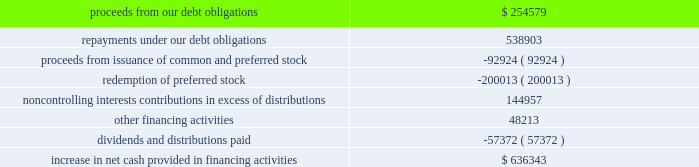Sl green realty corp .
It happens here 2012 annual report 59 | 59 during the year ended december a031 , 2012 , when compared to the year ended december a031 , 2011 , we used cash for the follow- ing financing activities ( in thousands ) : .
Ca pita liz ation | as of december a0 31 , 2012 , we had 91249632 shares of common stock , 2759758 units of lim- ited partnership interest in the operating partnership held by persons other than the company , 66668 a0 performance based ltip units , 7700000 a0 shares of our 7.625% ( 7.625 % ) series a0 c cumulative redeemable preferred stock , or series c preferred stock , and 9200000 a0 shares of our 6.50% ( 6.50 % ) series a0 i cumula- tive redeemable preferred stock , or series a0 i preferred stock , outstanding .
In addition , we also had preferred units of limited partnership interests in the operating partnership having aggregate liquidation preferences of $ 49.6 a0million held by per- sons other than the company .
In september a0 2012 , we redeemed 4000000 a0 shares , or $ 100.0 a0 million , of series c preferred stock at a redemp- tion price of $ 25.00 a0 per share plus a0 $ 0.3707 in accumu- lated and unpaid dividends on such preferred stock through september a0 24 , 2012 .
We recognized $ 6.3 a0 million of costs to partially redeem the series c preferred stock .
As a result of this redemption , we have 7700000 a0 shares of series a0 c preferred stock outstanding .
In august a0 2012 , we issued 9200000 a0 shares of our series a0 i preferred stock with a mandatory liquidation pref- erence of $ 25.00 a0 per share .
The series a0 i preferred share- holders receive annual distributions of $ 1.625 a0per share paid on a quarterly basis and distributions are cumulative , sub- ject to certain provisions .
We are entitled to redeem our series a0i preferred stock at par for cash at our option on or after august a0 10 , 2017 .
Net proceeds from the series i preferred stock ( $ 222.2 a0million ) was recorded net of underwriters 2019 dis- count and issuance a0costs .
In july a0 2012 , we redeemed all 4000000 a0 shares , or $ 100.0 a0million , of our 7.875% ( 7.875 % ) series a0d cumulative redeemable preferred stock , or series a0d preferred stock , at a redemption price of $ 25.00 a0 per share plus $ 0.4922 in accumulated and unpaid dividends on such preferred stock through july a0 14 , 2012 .
We recognized $ 3.7 a0million of costs to fully redeem the series a0d preferred stock .
In july a0 2011 , we , along with the operating partnership , entered into an 201cat-the-market 201d equity offering program , or atm program , to sell an aggregate of $ 250.0 a0 million of our common stock .
During the year ended december a0 31 , 2012 , we sold 2.6 a0 million shares of our common stock through the atm program for aggregate gross proceeds of approximately $ 204.6 a0 million ( $ 201.3 a0 million of net proceeds after related expenses ) .
The net proceeds were used to repay debt , fund new investments and for other corporate purposes .
As of december a0 31 , 2012 , we had $ 45.4 a0 million available to issue under the atm a0program .
Dividend reinvestment and stock purchase plan | in march a0 2012 , we filed a registration statement with the sec for our dividend reinvestment and stock purchase plan , or drip , which automatically became effective upon filing .
We registered 3500000 a0shares of common stock under the drip .
The drip commenced on september a024 , 2001 .
During the years ended december a0 31 , 2012 and 2011 , we issued approximately 1.3 a0 million and 473 a0 shares of our common stock and received approximately $ 99.6 a0million and $ 34000 of net proceeds , respectively , from dividend reinvest- ments and/or stock purchases under the drip .
Drip shares may be issued at a discount to the market price .
Second amended and restated 2005 stock option and incentive plan | subject to adjustments upon cer- tain corporate transactions or events , up to a maximum of 10730000 a0 fungible units may be granted as options , restricted stock , phantom shares , dividend equivalent rights and other equity based awards under the second amended and restated 2005 a0 stock option and incentive plan , or the 2005 a0plan .
As of december a031 , 2012 , no fungible units were available for issuance under the 2005 a0plan after reserving for shares underlying outstanding restricted stock units , phantom stock units granted pursuant to our non-employee directors 2019 deferral program and ltip units , including , among others , outstanding ltip units issued under our 2011 a0 long-term outperformance plan , which remain subject to performance based a0vesting .
2005 long-ter m outper for m a nce compensation program | in december a0 2005 , the compensation commit- tee of our board of directors approved a long-term incentive compensation program , the 2005 a0 outperformance plan .
Participants in the 2005 a0 outperformance plan were enti- tled to earn ltip a0 units in our operating partnership if our total return to stockholders for the three-year period beginning december a0 1 , 2005 exceeded a cumulative total return to stockholders of 30% ( 30 % ) ; provided that participants were entitled to earn ltip units earlier in the event that we achieved maximum performance for 30 consecutive days .
On june a014 , 2006 , the compensation committee determined that under the terms of the 2005 a0 outperformance plan , as of june a0 8 , 2006 , the performance period had accelerated and the maximum performance pool of $ 49250000 , taking into account forfeitures , had been earned .
Under the terms of the 2005 a0 outperformance plan , participants also earned additional ltip a0units with a value equal to the distributions .
For the september 2012 redemption of 4000000 shares of series c preferred stock at a redemption price , what percentage were the costs to redeem the series c preferred stock? 
Computations: (6.3 / 100)
Answer: 0.063. 